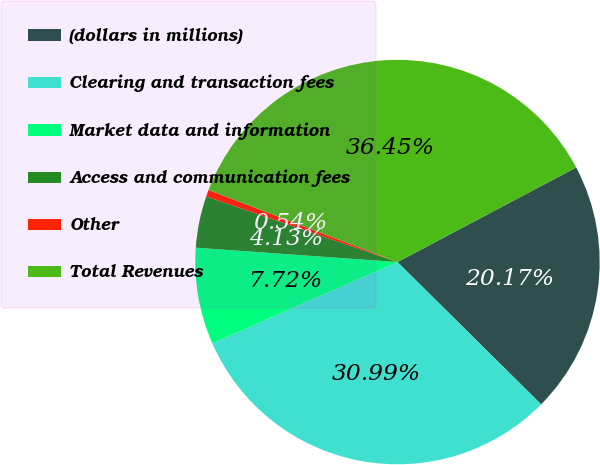Convert chart to OTSL. <chart><loc_0><loc_0><loc_500><loc_500><pie_chart><fcel>(dollars in millions)<fcel>Clearing and transaction fees<fcel>Market data and information<fcel>Access and communication fees<fcel>Other<fcel>Total Revenues<nl><fcel>20.17%<fcel>30.99%<fcel>7.72%<fcel>4.13%<fcel>0.54%<fcel>36.45%<nl></chart> 